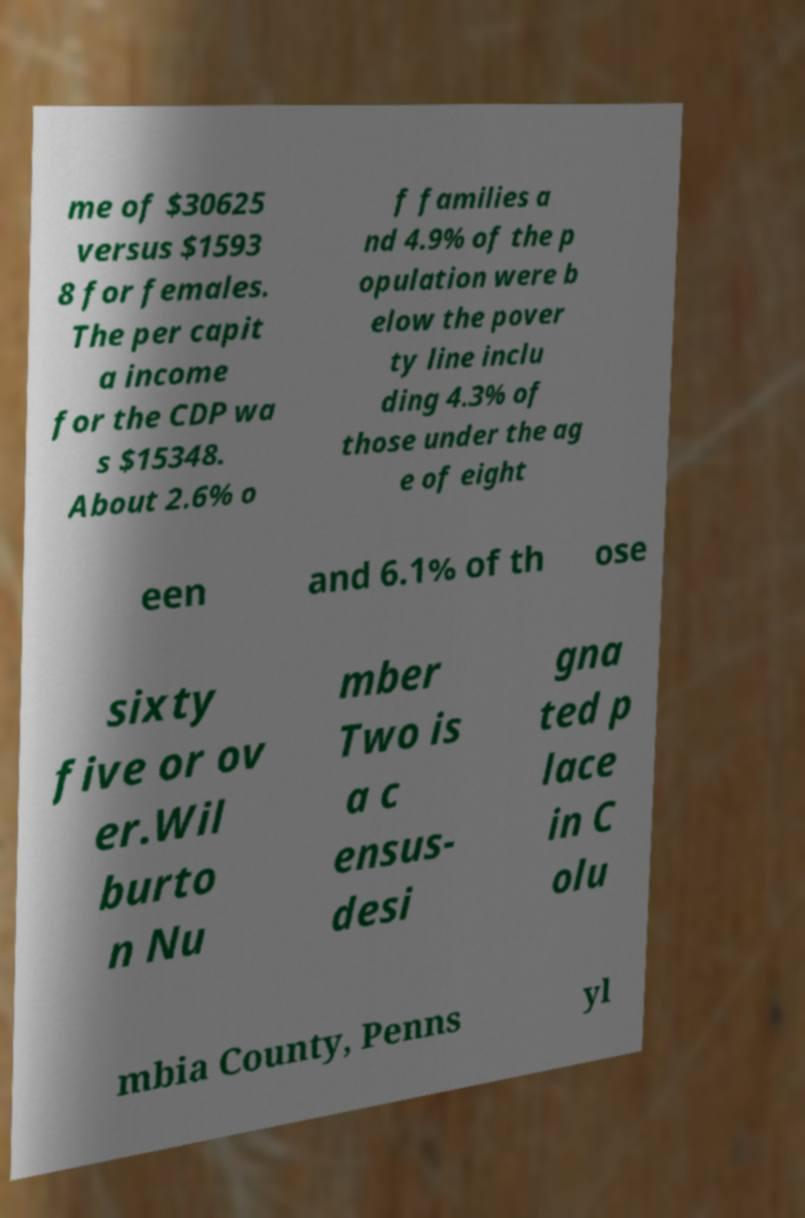Please identify and transcribe the text found in this image. me of $30625 versus $1593 8 for females. The per capit a income for the CDP wa s $15348. About 2.6% o f families a nd 4.9% of the p opulation were b elow the pover ty line inclu ding 4.3% of those under the ag e of eight een and 6.1% of th ose sixty five or ov er.Wil burto n Nu mber Two is a c ensus- desi gna ted p lace in C olu mbia County, Penns yl 